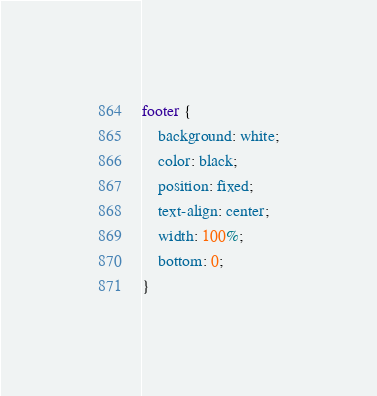Convert code to text. <code><loc_0><loc_0><loc_500><loc_500><_CSS_>footer {
    background: white;
    color: black;
    position: fixed;
    text-align: center;
    width: 100%;
    bottom: 0;
}</code> 